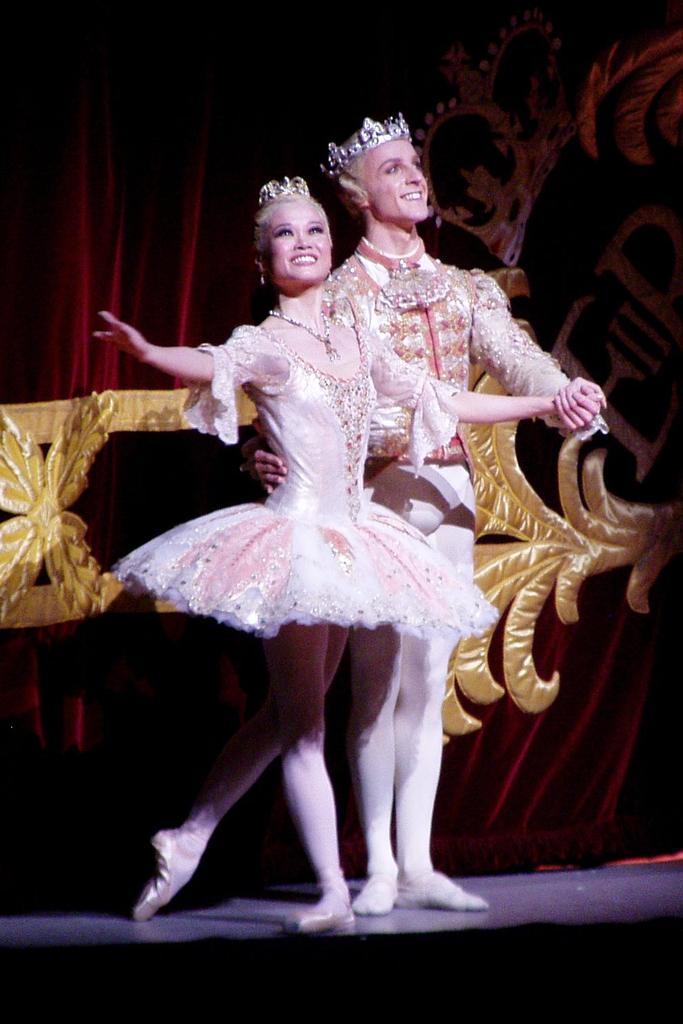Describe this image in one or two sentences. In the picture I can see a couple standing on the floor and looks like they are dancing. I can see the smile on their faces and I can see the crown on their head. In the background, I can see a red color design cloth. 